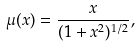<formula> <loc_0><loc_0><loc_500><loc_500>\mu ( x ) = \frac { x } { ( 1 + x ^ { 2 } ) ^ { 1 / 2 } } ,</formula> 